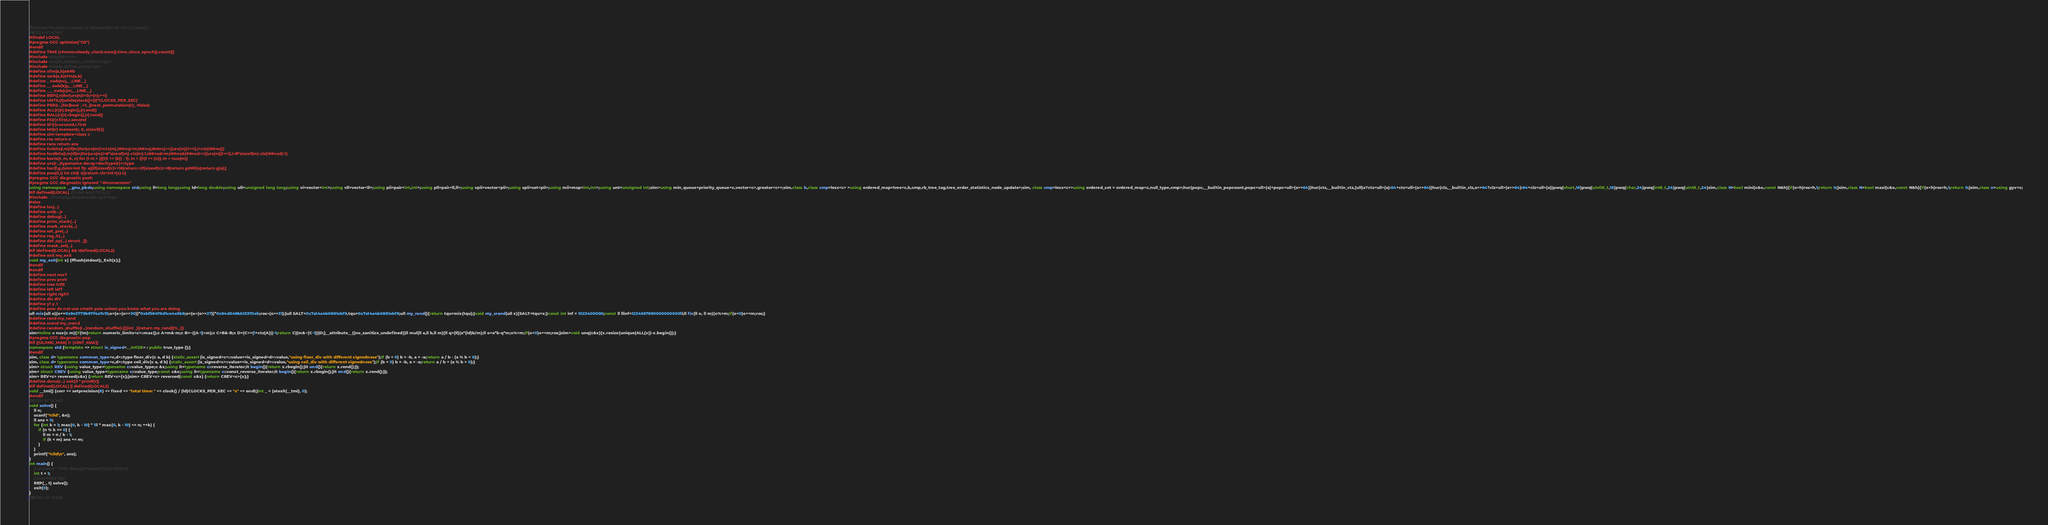<code> <loc_0><loc_0><loc_500><loc_500><_C++_>//Konrad Paluszek,University of Warsaw(former XIV LO Staszic)
//#STAY AT HOME
#ifndef LOCAL
#pragma GCC optimize("O3")
#endif
#define TIME (chrono::steady_clock::now().time_since_epoch().count())
#include<bits/stdc++.h>
#include<ext/pb_ds/assoc_container.hpp>
#include<ext/pb_ds/tree_policy.hpp>
#define xfm(a,b)a##b
#define xwb(a,b)xfm(a,b)
#define _ xwb(nvj,__LINE__)
#define __ xwb(kjy,__LINE__)
#define ___ xwb(cjm,__LINE__)
#define REP(i,n)for(urs(n)i=0;i<(n);++i)
#define UNTIL(t)while(clock()<(t)*CLOCKS_PER_SEC)
#define PER(r...)for(bool _=1;_||next_permutation(r);_=false)
#define ALL(r)(r).begin(),(r).end()
#define RALL(r)(r).rbegin(),(r).rend()
#define FS(r)r.first,r.second
#define SF(r)r.second,r.first
#define M0(r) memset(r, 0, sizeof(r))
#define sim template<class c
#define ros return o
#define rans return ans
#define forbits(i,m)if(m)for(urs(m)i=ctz(m),i##nvj=m;i##nvj;i##nvj^=((urs(m))1<<i),i=ctz(i##nvj))
#define fordbits(i,m)if(m)for(urs(m)i=8*sizeof(m)-clz(m)-1,i##nxd=m;i##nxd;i##nxd^=((urs(m))1<<i),i=8*sizeof(m)-clz(i##nxd)-1)
#define ksets(t, m, k, n) for (t m = (((t)1 << (k)) - 1); m < ((t)1 << (n)); m = nux(m))
#define urs(r...)typename decay<decltype(r)>::type
#define hur(f,g,r)sim>int f(c a){if(sizeof(c)==16)return r;if(sizeof(c)==8)return g##ll(a);return g(a);}
#define pwq(t,i) int clz(t x){return clz<int>(x)-i;}
#pragma GCC diagnostic push
#pragma GCC diagnostic ignored "-Wconversion"
using namespace __gnu_pbds;using namespace std;using ll=long long;using ld=long double;using ull=unsigned long long;using vi=vector<int>;using vll=vector<ll>;using pii=pair<int,int>;using pll=pair<ll,ll>;using vpii=vector<pii>;using spii=set<pii>;using mii=map<int,int>;using unt=unsigned int;sim>using min_queue=priority_queue<c,vector<c>,greater<c>>;sim,class b,class cmp=less<c> >using ordered_map=tree<c,b,cmp,rb_tree_tag,tree_order_statistics_node_update>;sim, class cmp=less<c>>using ordered_set = ordered_map<c,null_type,cmp>;hur(popc,__builtin_popcount,popc<ull>(a)+popc<ull>(a>>64))hur(ctz,__builtin_ctz,(ull)a?ctz<ull>(a):64+ctz<ull>(a>>64))hur(clz,__builtin_clz,a>>64?clz<ull>(a>>64):64+clz<ull>(a))pwq(short,16)pwq(uint16_t,16)pwq(char,24)pwq(int8_t,24)pwq(uint8_t,24)sim,class N>bool mini(c&o,const N&h){if(o>h)ros=h,1;return 0;}sim,class N>bool maxi(c&o,const N&h){if(o<h)ros=h,1;return 0;}sim,class n>using gyv=c;
#if defined(LOCAL) // || defined(LOCAL2)
#include </home/kjp/headers/debuglib.hpp>
#else
#define loc(...)
#define onl(r...)r
#define debug(...)
#define print_stack(...)
#define mark_stack(...)
#define set_pre(...)
#define reg_it(...)
#define def_op(...) struct _{};
#define mask_set(...)
#if !defined(LOCAL) && !defined(LOCAL2)
#define exit my_exit
void my_exit(int x) {fflush(stdout);_Exit(x);}
#endif
#endif
#define next nexT
#define prev preV
#define tree trEE
#define left lefT
#define right righT
#define div diV
#define y1 y_1
#define pow do not use cmath pow unless you know what you are doing
ull mix(ull o){o+=0x9e3779b97f4a7c15;o=(o^(o>>30))*0xbf58476d1ce4e5b9;o=(o^(o>>27))*0x94d049bb133111eb;ros^(o>>31);}ull SALT=0x7a14a4b0881ebf9,tqu=0x7a14a4b0881ebf9;ull my_rand(){return tqu=mix(tqu);}void my_srand(ull x){SALT=tqu=x;}const int inf = 1023400000;const ll llinf=1234567890000000000ll;ll fix(ll o, ll m){o%=m;if(o<0)o+=m;ros;}
#define rand my_rand
#define srand my_srand
#define random_shuffle(r...)random_shuffle(r,[](int _){return my_rand()%_;})
sim>inline c nux(c m){if(!m)return numeric_limits<c>::max();c A=m&-m;c B=~((A-1)^m);c C=B&-B;c D=(C>>(1+ctz(A)))-1;return C|(m&~(C-1))|D;}__attribute__((no_sanitize_undefined))ll mul(ll a,ll b,ll m){ll q=(ll)(a*(ld)b/m);ll o=a*b-q*m;o%=m;if(o<0)o+=m;ros;}sim>void unq(c&x){x.resize(unique(ALL(x))-x.begin());}
#pragma GCC diagnostic pop
#if ((ULONG_MAX) != (UINT_MAX))
namespace std {template <> struct is_signed<__int128> : public true_type {};}
#endif
sim, class d> typename common_type<c,d>::type floor_div(c a, d b) {static_assert(is_signed<c>::value==is_signed<d>::value,"using floor_div with different signedness");if (b < 0) b = -b, a = -a;return a / b - (a % b < 0);}
sim, class d> typename common_type<c,d>::type ceil_div(c a, d b) {static_assert(is_signed<c>::value==is_signed<d>::value,"using ceil_div with different signedness");if (b < 0) b = -b, a = -a;return a / b + (a % b > 0);}
sim> struct REV {using value_type=typename c::value_type;c &x;using it=typename c::reverse_iterator;it begin(){return x.rbegin();}it end(){return x.rend();}};
sim> struct CREV {using value_type=typename c::value_type;const c&x;using it=typename c::const_reverse_iterator;it begin(){return x.rbegin();}it end(){return x.rend();}};
sim> REV<c> reversed(c&x) {return REV<c>{x};}sim> CREV<c> reversed(const c&x) {return CREV<c>{x};}
#define done(r...) exit(0 * printf(r))
#if defined(LOCAL) || defined(LOCAL2)
void __tmi() {cerr << setprecision(6) << fixed << "total time: " << clock() / (ld)CLOCKS_PER_SEC << "s" << endl;}int _ = (atexit(__tmi), 0);
#endif
//#STAY AT HOME
void solve() {
	ll n;
	scanf("%lld", &n);
	ll ans = 0;
	for (int k = 1; max(0, k - 10) * 1ll * max(0, k - 10) <= n; ++k) {
		if (n % k == 0) {
			ll m = n / k - 1;
			if (k < m) ans += m;
		}
	}
	printf("%lld\n", ans);
}
int main() {
	// unt seed = TIME; debug(imie(seed));srand(seed);
	int t = 1;
	// scanf("%d", &t);
	REP(_, t) solve();
	exit(0);
}
//#STAY AT HOME
</code> 